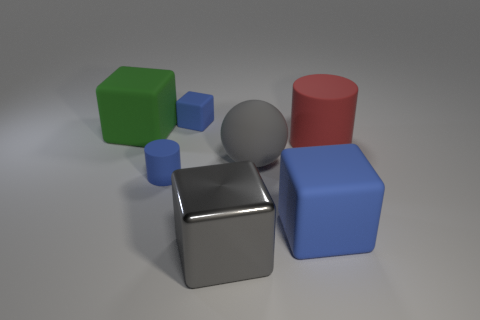Add 1 tiny brown matte spheres. How many objects exist? 8 Subtract all blocks. How many objects are left? 3 Subtract all tiny blue rubber blocks. Subtract all metal blocks. How many objects are left? 5 Add 6 large red objects. How many large red objects are left? 7 Add 1 yellow metallic blocks. How many yellow metallic blocks exist? 1 Subtract 0 red cubes. How many objects are left? 7 